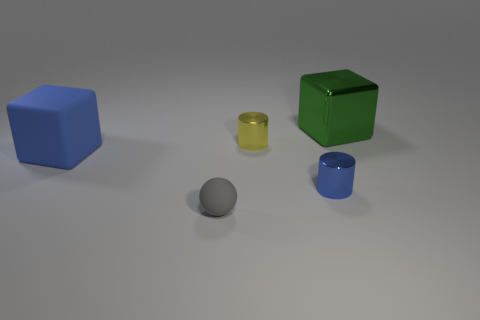Are there any objects of the same color but different shapes? Yes, there are objects with differing shapes but the same color. The small yellow cylinder and the large green cube share a hue of yellow-green, although their shades have a slight variance.  Can you describe the arrangement of objects in terms of their relative positions? Certainly. Starting from the left side, you have the large blue cube. In front of it is a small yellow cylinder, and next to the cylinder on the right is the large green cube. To the right of the green cube, there is a large blue cylinder, and in the very front, closer to the perspective of the viewer, is a small gray sphere. 